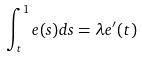<formula> <loc_0><loc_0><loc_500><loc_500>\int _ { t } ^ { 1 } e ( s ) d s = \lambda e ^ { \prime } ( t )</formula> 